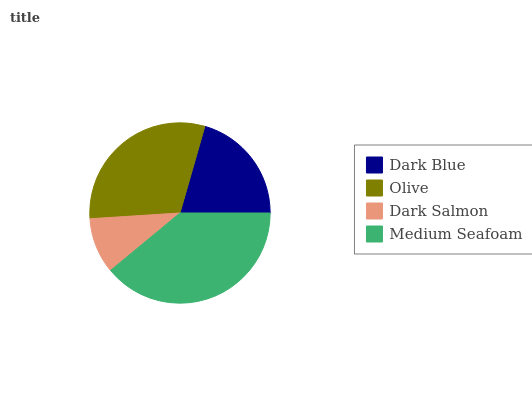Is Dark Salmon the minimum?
Answer yes or no. Yes. Is Medium Seafoam the maximum?
Answer yes or no. Yes. Is Olive the minimum?
Answer yes or no. No. Is Olive the maximum?
Answer yes or no. No. Is Olive greater than Dark Blue?
Answer yes or no. Yes. Is Dark Blue less than Olive?
Answer yes or no. Yes. Is Dark Blue greater than Olive?
Answer yes or no. No. Is Olive less than Dark Blue?
Answer yes or no. No. Is Olive the high median?
Answer yes or no. Yes. Is Dark Blue the low median?
Answer yes or no. Yes. Is Medium Seafoam the high median?
Answer yes or no. No. Is Medium Seafoam the low median?
Answer yes or no. No. 